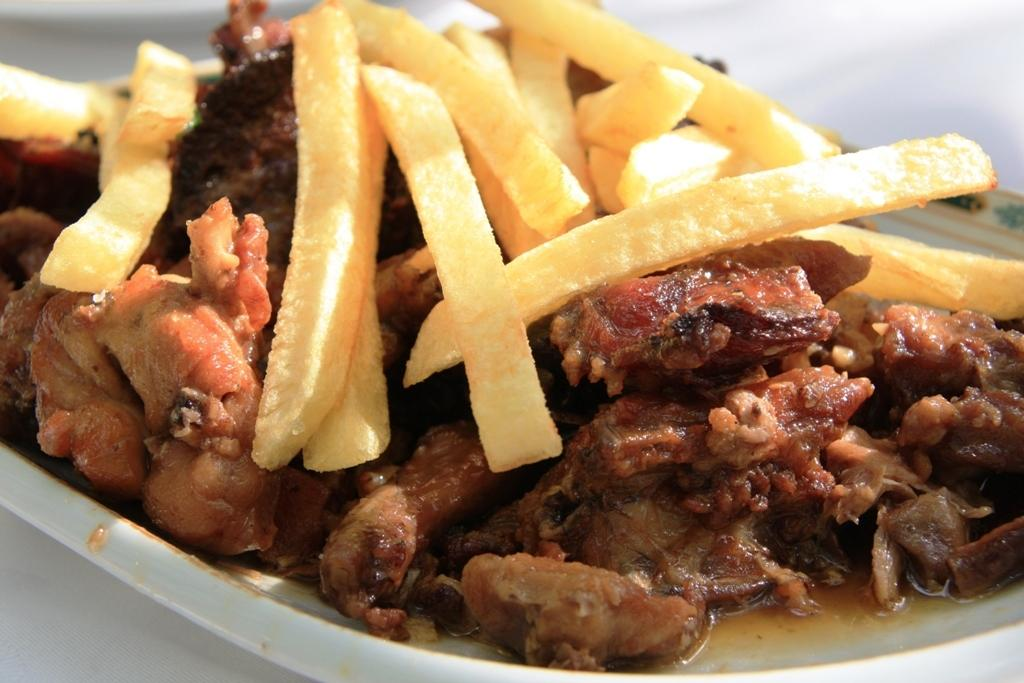What piece of furniture is present in the image? There is a table in the image. What is on the table in the image? There is a plate containing food in the image. What type of food can be seen on the plate? There are fries on the plate. What color is the yoke on the plate in the image? There is no yoke present on the plate in the image. Is the food on the plate in a liquid form? No, the food on the plate consists of fries, which are not in a liquid form. 